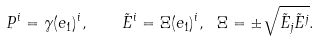<formula> <loc_0><loc_0><loc_500><loc_500>P ^ { i } = \gamma ( e _ { 1 } ) ^ { i } , \quad \tilde { E } ^ { i } = \Xi ( e _ { 1 } ) ^ { i } , \ \Xi = \pm \sqrt { \tilde { E } _ { j } \tilde { E } ^ { j } } .</formula> 